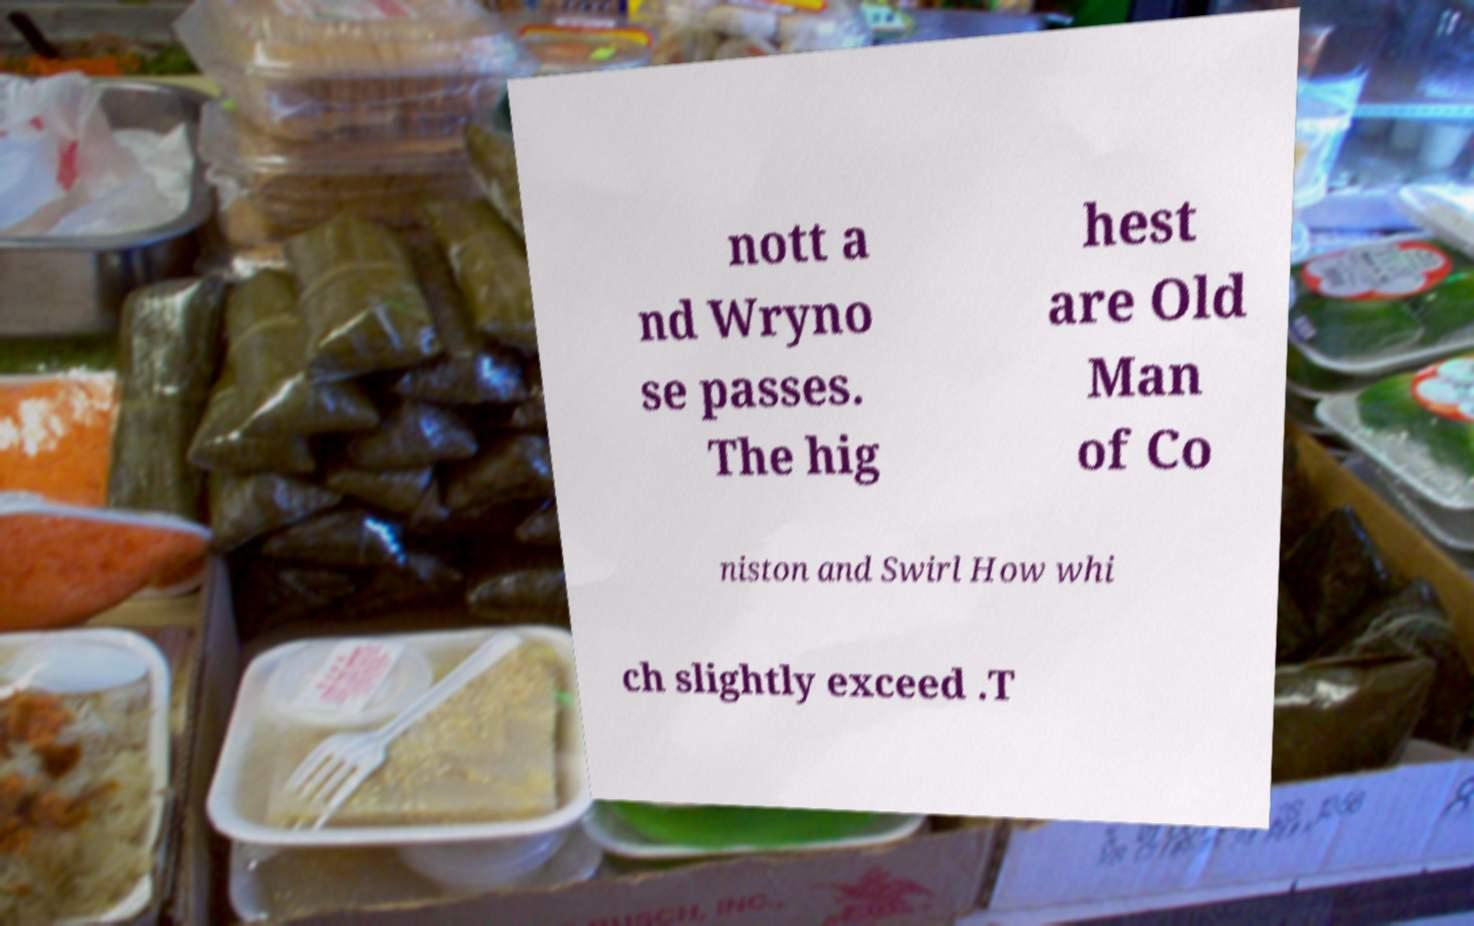Can you read and provide the text displayed in the image?This photo seems to have some interesting text. Can you extract and type it out for me? nott a nd Wryno se passes. The hig hest are Old Man of Co niston and Swirl How whi ch slightly exceed .T 